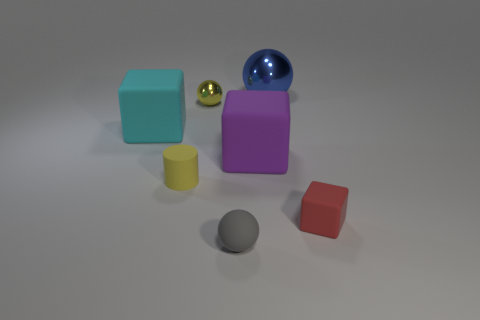There is a matte cube that is on the right side of the cylinder and left of the small cube; how big is it?
Offer a terse response. Large. What number of gray objects are tiny metal things or tiny rubber spheres?
Your answer should be compact. 1. What shape is the yellow thing that is the same size as the yellow cylinder?
Your answer should be very brief. Sphere. How many other things are the same color as the matte cylinder?
Make the answer very short. 1. What is the size of the matte cube that is left of the small ball in front of the yellow matte thing?
Your answer should be compact. Large. Does the object to the right of the large blue metallic object have the same material as the cyan thing?
Make the answer very short. Yes. There is a tiny rubber object behind the small red rubber block; what shape is it?
Offer a very short reply. Cylinder. What number of other matte cylinders have the same size as the yellow rubber cylinder?
Offer a terse response. 0. What is the size of the yellow rubber cylinder?
Provide a short and direct response. Small. There is a large blue shiny sphere; how many small yellow spheres are in front of it?
Provide a succinct answer. 1. 